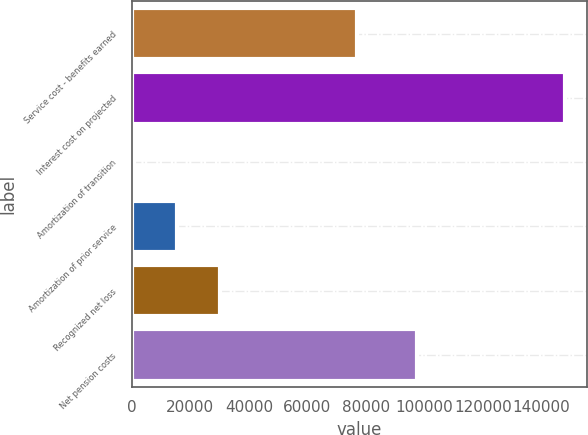Convert chart to OTSL. <chart><loc_0><loc_0><loc_500><loc_500><bar_chart><fcel>Service cost - benefits earned<fcel>Interest cost on projected<fcel>Amortization of transition<fcel>Amortization of prior service<fcel>Recognized net loss<fcel>Net pension costs<nl><fcel>76946<fcel>148092<fcel>763<fcel>15495.9<fcel>30228.8<fcel>97521<nl></chart> 